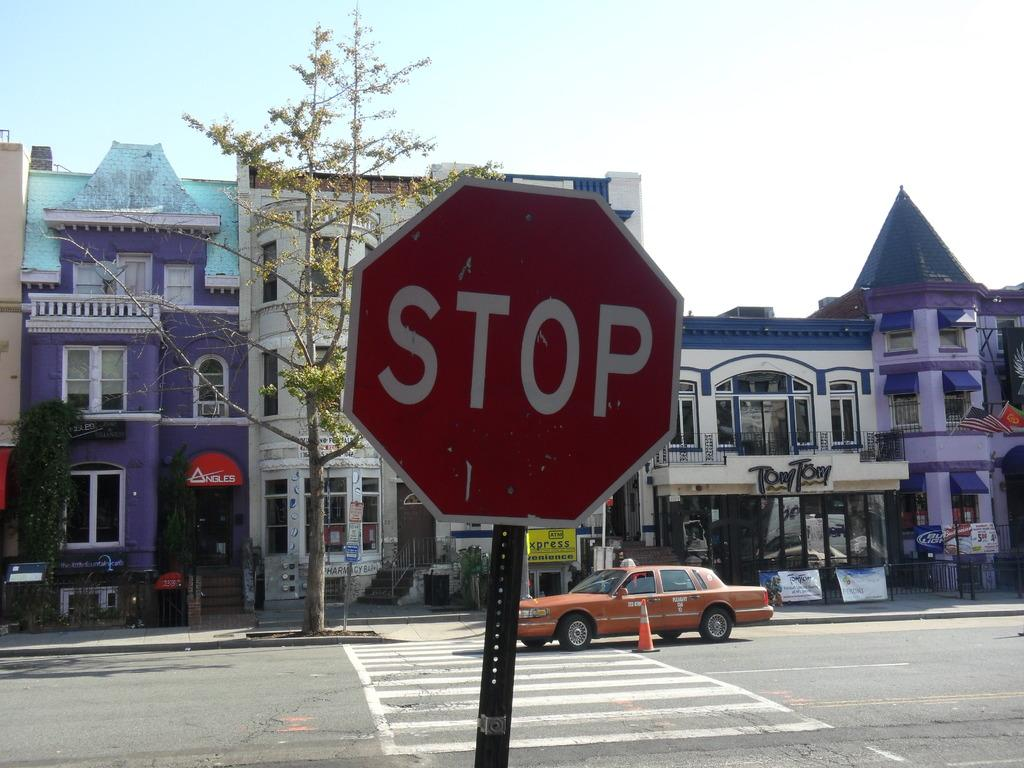<image>
Present a compact description of the photo's key features. A stop sign stands in front of a high building with a car park in front. 